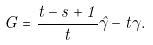<formula> <loc_0><loc_0><loc_500><loc_500>G = \frac { t - s + 1 } { t } \hat { \gamma } - t \gamma .</formula> 